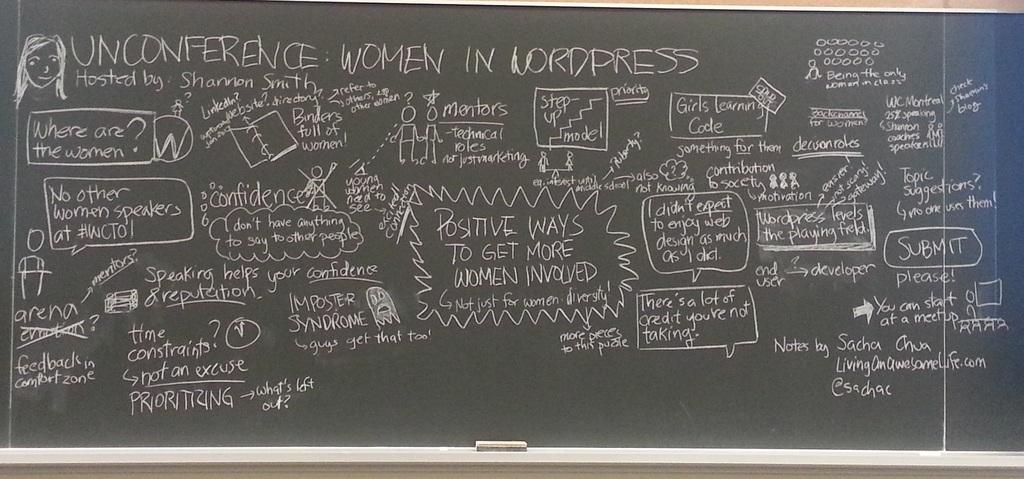<image>
Offer a succinct explanation of the picture presented. Alot of writing is on a board starting with a picture of a woman at the top and the word unconference. 